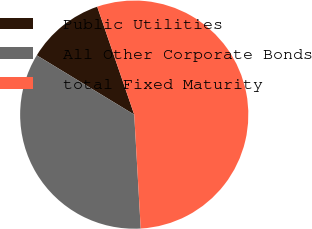Convert chart to OTSL. <chart><loc_0><loc_0><loc_500><loc_500><pie_chart><fcel>Public Utilities<fcel>All Other Corporate Bonds<fcel>total Fixed Maturity<nl><fcel>11.04%<fcel>34.61%<fcel>54.36%<nl></chart> 